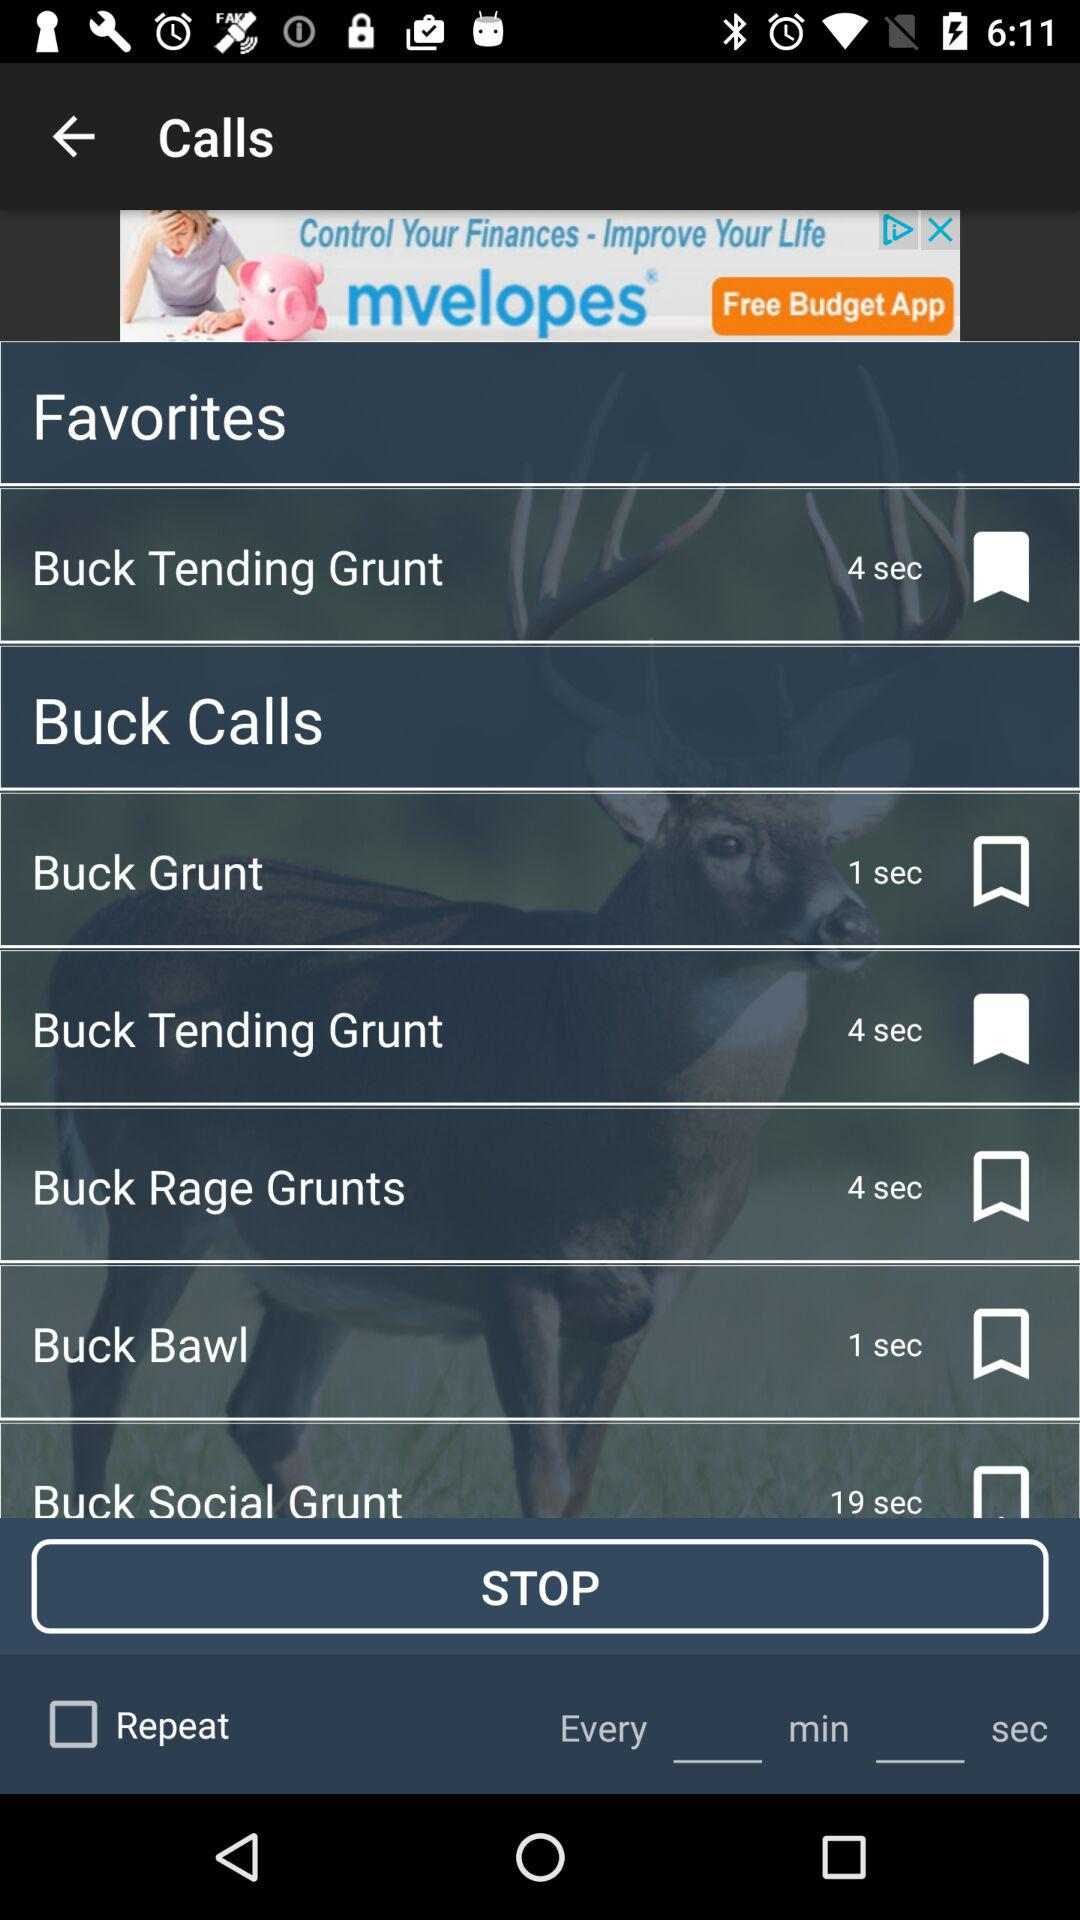What name is bookmarked in "Favorites" in "Calls"? The bookmarked name is "Buck Tending Grunt". 